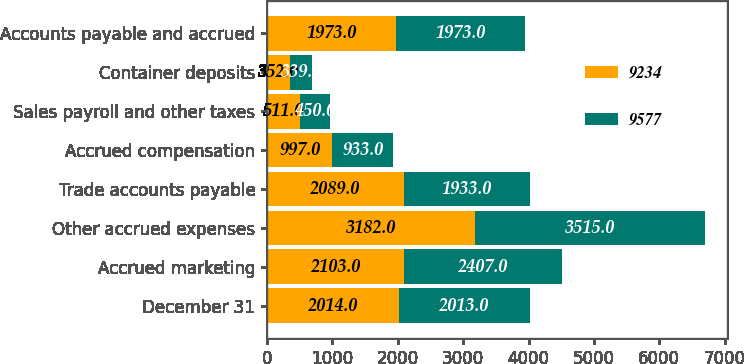<chart> <loc_0><loc_0><loc_500><loc_500><stacked_bar_chart><ecel><fcel>December 31<fcel>Accrued marketing<fcel>Other accrued expenses<fcel>Trade accounts payable<fcel>Accrued compensation<fcel>Sales payroll and other taxes<fcel>Container deposits<fcel>Accounts payable and accrued<nl><fcel>9234<fcel>2014<fcel>2103<fcel>3182<fcel>2089<fcel>997<fcel>511<fcel>352<fcel>1973<nl><fcel>9577<fcel>2013<fcel>2407<fcel>3515<fcel>1933<fcel>933<fcel>450<fcel>339<fcel>1973<nl></chart> 